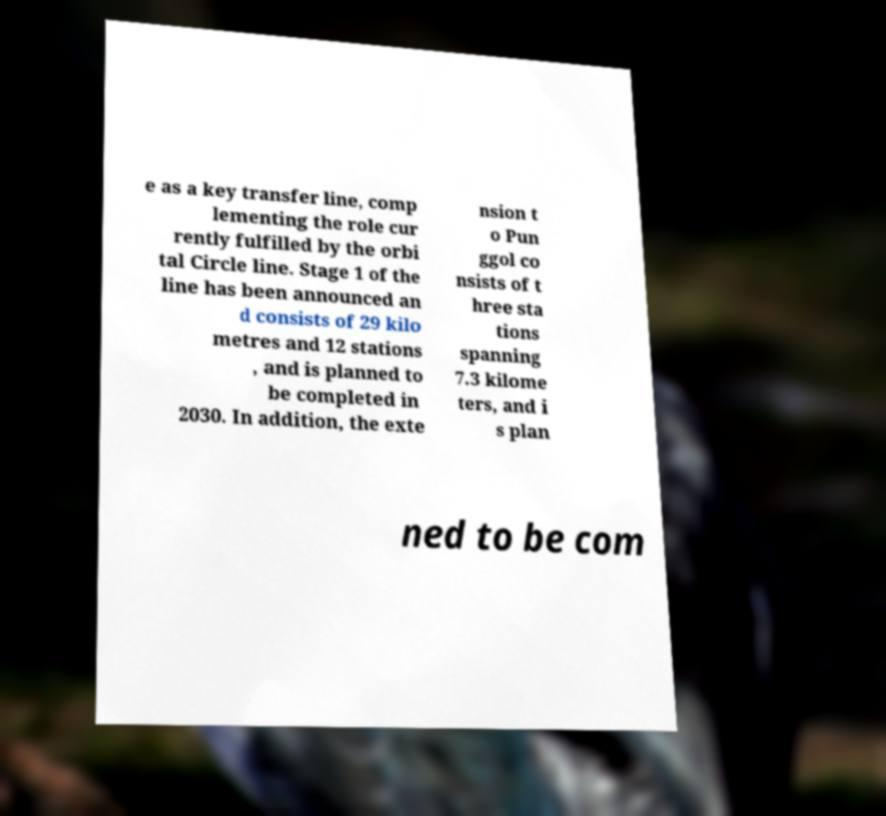What messages or text are displayed in this image? I need them in a readable, typed format. e as a key transfer line, comp lementing the role cur rently fulfilled by the orbi tal Circle line. Stage 1 of the line has been announced an d consists of 29 kilo metres and 12 stations , and is planned to be completed in 2030. In addition, the exte nsion t o Pun ggol co nsists of t hree sta tions spanning 7.3 kilome ters, and i s plan ned to be com 